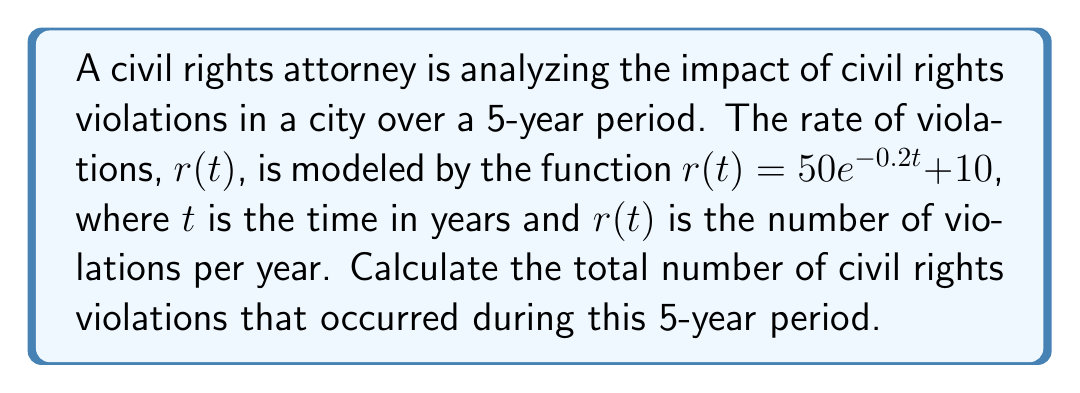Provide a solution to this math problem. To determine the total number of civil rights violations over the 5-year period, we need to integrate the rate function $r(t)$ from $t=0$ to $t=5$. This can be done using the following steps:

1) Set up the definite integral:
   $$\int_0^5 r(t) dt = \int_0^5 (50e^{-0.2t} + 10) dt$$

2) Split the integral:
   $$\int_0^5 50e^{-0.2t} dt + \int_0^5 10 dt$$

3) Integrate each part:
   For $\int_0^5 50e^{-0.2t} dt$:
   $$-250e^{-0.2t}\bigg|_0^5$$
   
   For $\int_0^5 10 dt$:
   $$10t\bigg|_0^5$$

4) Evaluate the antiderivatives at the limits:
   $$(-250e^{-0.2(5)} - (-250e^{-0.2(0)})) + (10(5) - 10(0))$$

5) Simplify:
   $$(-250(e^{-1}) + 250) + 50$$
   $$= -250(0.3679) + 250 + 50$$
   $$= -91.975 + 250 + 50$$
   $$= 208.025$$

Therefore, the total number of civil rights violations over the 5-year period is approximately 208.025.
Answer: 208.025 violations 